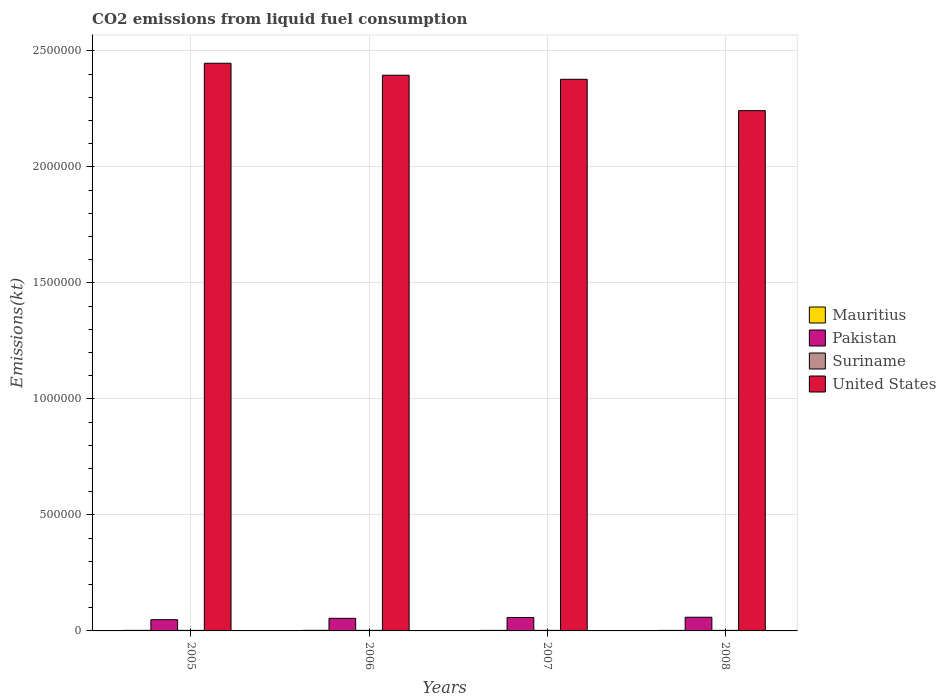How many groups of bars are there?
Provide a short and direct response. 4. Are the number of bars per tick equal to the number of legend labels?
Give a very brief answer. Yes. Are the number of bars on each tick of the X-axis equal?
Ensure brevity in your answer.  Yes. What is the label of the 3rd group of bars from the left?
Give a very brief answer. 2007. What is the amount of CO2 emitted in United States in 2008?
Provide a short and direct response. 2.24e+06. Across all years, what is the maximum amount of CO2 emitted in Pakistan?
Provide a short and direct response. 5.90e+04. Across all years, what is the minimum amount of CO2 emitted in Suriname?
Provide a short and direct response. 2346.88. What is the total amount of CO2 emitted in Mauritius in the graph?
Give a very brief answer. 9526.87. What is the difference between the amount of CO2 emitted in United States in 2005 and that in 2008?
Your response must be concise. 2.04e+05. What is the difference between the amount of CO2 emitted in United States in 2007 and the amount of CO2 emitted in Suriname in 2005?
Make the answer very short. 2.37e+06. What is the average amount of CO2 emitted in United States per year?
Provide a short and direct response. 2.37e+06. In the year 2006, what is the difference between the amount of CO2 emitted in Pakistan and amount of CO2 emitted in Mauritius?
Provide a short and direct response. 5.18e+04. In how many years, is the amount of CO2 emitted in Mauritius greater than 2200000 kt?
Make the answer very short. 0. Is the difference between the amount of CO2 emitted in Pakistan in 2006 and 2008 greater than the difference between the amount of CO2 emitted in Mauritius in 2006 and 2008?
Offer a terse response. No. What is the difference between the highest and the second highest amount of CO2 emitted in Pakistan?
Ensure brevity in your answer.  1052.43. What is the difference between the highest and the lowest amount of CO2 emitted in Mauritius?
Your response must be concise. 267.69. Is the sum of the amount of CO2 emitted in Suriname in 2005 and 2008 greater than the maximum amount of CO2 emitted in Mauritius across all years?
Offer a very short reply. Yes. Is it the case that in every year, the sum of the amount of CO2 emitted in Mauritius and amount of CO2 emitted in United States is greater than the sum of amount of CO2 emitted in Pakistan and amount of CO2 emitted in Suriname?
Give a very brief answer. Yes. What does the 2nd bar from the left in 2006 represents?
Offer a terse response. Pakistan. What does the 1st bar from the right in 2008 represents?
Your response must be concise. United States. Are all the bars in the graph horizontal?
Give a very brief answer. No. What is the difference between two consecutive major ticks on the Y-axis?
Provide a succinct answer. 5.00e+05. Does the graph contain any zero values?
Offer a very short reply. No. Where does the legend appear in the graph?
Your answer should be compact. Center right. What is the title of the graph?
Make the answer very short. CO2 emissions from liquid fuel consumption. What is the label or title of the Y-axis?
Provide a succinct answer. Emissions(kt). What is the Emissions(kt) in Mauritius in 2005?
Your response must be concise. 2442.22. What is the Emissions(kt) of Pakistan in 2005?
Provide a short and direct response. 4.84e+04. What is the Emissions(kt) of Suriname in 2005?
Provide a short and direct response. 2346.88. What is the Emissions(kt) of United States in 2005?
Offer a terse response. 2.45e+06. What is the Emissions(kt) in Mauritius in 2006?
Offer a very short reply. 2493.56. What is the Emissions(kt) of Pakistan in 2006?
Your response must be concise. 5.43e+04. What is the Emissions(kt) in Suriname in 2006?
Your response must be concise. 2409.22. What is the Emissions(kt) in United States in 2006?
Provide a succinct answer. 2.39e+06. What is the Emissions(kt) of Mauritius in 2007?
Your response must be concise. 2365.22. What is the Emissions(kt) of Pakistan in 2007?
Provide a succinct answer. 5.79e+04. What is the Emissions(kt) of Suriname in 2007?
Your answer should be compact. 2409.22. What is the Emissions(kt) of United States in 2007?
Provide a succinct answer. 2.38e+06. What is the Emissions(kt) of Mauritius in 2008?
Your response must be concise. 2225.87. What is the Emissions(kt) in Pakistan in 2008?
Make the answer very short. 5.90e+04. What is the Emissions(kt) in Suriname in 2008?
Keep it short and to the point. 2409.22. What is the Emissions(kt) in United States in 2008?
Offer a very short reply. 2.24e+06. Across all years, what is the maximum Emissions(kt) of Mauritius?
Keep it short and to the point. 2493.56. Across all years, what is the maximum Emissions(kt) in Pakistan?
Your response must be concise. 5.90e+04. Across all years, what is the maximum Emissions(kt) in Suriname?
Your response must be concise. 2409.22. Across all years, what is the maximum Emissions(kt) of United States?
Provide a succinct answer. 2.45e+06. Across all years, what is the minimum Emissions(kt) of Mauritius?
Your answer should be very brief. 2225.87. Across all years, what is the minimum Emissions(kt) of Pakistan?
Make the answer very short. 4.84e+04. Across all years, what is the minimum Emissions(kt) of Suriname?
Make the answer very short. 2346.88. Across all years, what is the minimum Emissions(kt) of United States?
Keep it short and to the point. 2.24e+06. What is the total Emissions(kt) of Mauritius in the graph?
Keep it short and to the point. 9526.87. What is the total Emissions(kt) in Pakistan in the graph?
Provide a succinct answer. 2.20e+05. What is the total Emissions(kt) of Suriname in the graph?
Make the answer very short. 9574.54. What is the total Emissions(kt) of United States in the graph?
Offer a very short reply. 9.46e+06. What is the difference between the Emissions(kt) in Mauritius in 2005 and that in 2006?
Keep it short and to the point. -51.34. What is the difference between the Emissions(kt) of Pakistan in 2005 and that in 2006?
Your response must be concise. -5859.87. What is the difference between the Emissions(kt) in Suriname in 2005 and that in 2006?
Provide a succinct answer. -62.34. What is the difference between the Emissions(kt) of United States in 2005 and that in 2006?
Ensure brevity in your answer.  5.15e+04. What is the difference between the Emissions(kt) in Mauritius in 2005 and that in 2007?
Give a very brief answer. 77.01. What is the difference between the Emissions(kt) in Pakistan in 2005 and that in 2007?
Keep it short and to the point. -9519.53. What is the difference between the Emissions(kt) in Suriname in 2005 and that in 2007?
Offer a very short reply. -62.34. What is the difference between the Emissions(kt) of United States in 2005 and that in 2007?
Offer a terse response. 6.92e+04. What is the difference between the Emissions(kt) in Mauritius in 2005 and that in 2008?
Keep it short and to the point. 216.35. What is the difference between the Emissions(kt) of Pakistan in 2005 and that in 2008?
Offer a terse response. -1.06e+04. What is the difference between the Emissions(kt) of Suriname in 2005 and that in 2008?
Keep it short and to the point. -62.34. What is the difference between the Emissions(kt) in United States in 2005 and that in 2008?
Your answer should be compact. 2.04e+05. What is the difference between the Emissions(kt) of Mauritius in 2006 and that in 2007?
Provide a short and direct response. 128.34. What is the difference between the Emissions(kt) in Pakistan in 2006 and that in 2007?
Keep it short and to the point. -3659.67. What is the difference between the Emissions(kt) in Suriname in 2006 and that in 2007?
Give a very brief answer. 0. What is the difference between the Emissions(kt) of United States in 2006 and that in 2007?
Provide a succinct answer. 1.77e+04. What is the difference between the Emissions(kt) of Mauritius in 2006 and that in 2008?
Your answer should be compact. 267.69. What is the difference between the Emissions(kt) of Pakistan in 2006 and that in 2008?
Keep it short and to the point. -4712.1. What is the difference between the Emissions(kt) of Suriname in 2006 and that in 2008?
Your answer should be compact. 0. What is the difference between the Emissions(kt) of United States in 2006 and that in 2008?
Offer a very short reply. 1.53e+05. What is the difference between the Emissions(kt) in Mauritius in 2007 and that in 2008?
Give a very brief answer. 139.35. What is the difference between the Emissions(kt) of Pakistan in 2007 and that in 2008?
Your answer should be very brief. -1052.43. What is the difference between the Emissions(kt) in Suriname in 2007 and that in 2008?
Offer a very short reply. 0. What is the difference between the Emissions(kt) of United States in 2007 and that in 2008?
Make the answer very short. 1.35e+05. What is the difference between the Emissions(kt) in Mauritius in 2005 and the Emissions(kt) in Pakistan in 2006?
Keep it short and to the point. -5.18e+04. What is the difference between the Emissions(kt) of Mauritius in 2005 and the Emissions(kt) of Suriname in 2006?
Your answer should be compact. 33. What is the difference between the Emissions(kt) in Mauritius in 2005 and the Emissions(kt) in United States in 2006?
Make the answer very short. -2.39e+06. What is the difference between the Emissions(kt) of Pakistan in 2005 and the Emissions(kt) of Suriname in 2006?
Offer a very short reply. 4.60e+04. What is the difference between the Emissions(kt) in Pakistan in 2005 and the Emissions(kt) in United States in 2006?
Your answer should be very brief. -2.35e+06. What is the difference between the Emissions(kt) of Suriname in 2005 and the Emissions(kt) of United States in 2006?
Keep it short and to the point. -2.39e+06. What is the difference between the Emissions(kt) in Mauritius in 2005 and the Emissions(kt) in Pakistan in 2007?
Give a very brief answer. -5.55e+04. What is the difference between the Emissions(kt) of Mauritius in 2005 and the Emissions(kt) of Suriname in 2007?
Your answer should be compact. 33. What is the difference between the Emissions(kt) of Mauritius in 2005 and the Emissions(kt) of United States in 2007?
Your answer should be very brief. -2.37e+06. What is the difference between the Emissions(kt) in Pakistan in 2005 and the Emissions(kt) in Suriname in 2007?
Your response must be concise. 4.60e+04. What is the difference between the Emissions(kt) of Pakistan in 2005 and the Emissions(kt) of United States in 2007?
Your answer should be compact. -2.33e+06. What is the difference between the Emissions(kt) of Suriname in 2005 and the Emissions(kt) of United States in 2007?
Your answer should be compact. -2.37e+06. What is the difference between the Emissions(kt) of Mauritius in 2005 and the Emissions(kt) of Pakistan in 2008?
Provide a short and direct response. -5.65e+04. What is the difference between the Emissions(kt) in Mauritius in 2005 and the Emissions(kt) in Suriname in 2008?
Provide a short and direct response. 33. What is the difference between the Emissions(kt) in Mauritius in 2005 and the Emissions(kt) in United States in 2008?
Your answer should be compact. -2.24e+06. What is the difference between the Emissions(kt) in Pakistan in 2005 and the Emissions(kt) in Suriname in 2008?
Make the answer very short. 4.60e+04. What is the difference between the Emissions(kt) of Pakistan in 2005 and the Emissions(kt) of United States in 2008?
Provide a short and direct response. -2.19e+06. What is the difference between the Emissions(kt) in Suriname in 2005 and the Emissions(kt) in United States in 2008?
Your answer should be compact. -2.24e+06. What is the difference between the Emissions(kt) in Mauritius in 2006 and the Emissions(kt) in Pakistan in 2007?
Ensure brevity in your answer.  -5.54e+04. What is the difference between the Emissions(kt) in Mauritius in 2006 and the Emissions(kt) in Suriname in 2007?
Provide a short and direct response. 84.34. What is the difference between the Emissions(kt) in Mauritius in 2006 and the Emissions(kt) in United States in 2007?
Provide a short and direct response. -2.37e+06. What is the difference between the Emissions(kt) in Pakistan in 2006 and the Emissions(kt) in Suriname in 2007?
Ensure brevity in your answer.  5.19e+04. What is the difference between the Emissions(kt) in Pakistan in 2006 and the Emissions(kt) in United States in 2007?
Offer a very short reply. -2.32e+06. What is the difference between the Emissions(kt) in Suriname in 2006 and the Emissions(kt) in United States in 2007?
Ensure brevity in your answer.  -2.37e+06. What is the difference between the Emissions(kt) of Mauritius in 2006 and the Emissions(kt) of Pakistan in 2008?
Provide a short and direct response. -5.65e+04. What is the difference between the Emissions(kt) of Mauritius in 2006 and the Emissions(kt) of Suriname in 2008?
Provide a succinct answer. 84.34. What is the difference between the Emissions(kt) in Mauritius in 2006 and the Emissions(kt) in United States in 2008?
Your answer should be compact. -2.24e+06. What is the difference between the Emissions(kt) of Pakistan in 2006 and the Emissions(kt) of Suriname in 2008?
Your answer should be very brief. 5.19e+04. What is the difference between the Emissions(kt) of Pakistan in 2006 and the Emissions(kt) of United States in 2008?
Give a very brief answer. -2.19e+06. What is the difference between the Emissions(kt) of Suriname in 2006 and the Emissions(kt) of United States in 2008?
Your response must be concise. -2.24e+06. What is the difference between the Emissions(kt) of Mauritius in 2007 and the Emissions(kt) of Pakistan in 2008?
Offer a terse response. -5.66e+04. What is the difference between the Emissions(kt) in Mauritius in 2007 and the Emissions(kt) in Suriname in 2008?
Ensure brevity in your answer.  -44. What is the difference between the Emissions(kt) in Mauritius in 2007 and the Emissions(kt) in United States in 2008?
Offer a terse response. -2.24e+06. What is the difference between the Emissions(kt) of Pakistan in 2007 and the Emissions(kt) of Suriname in 2008?
Give a very brief answer. 5.55e+04. What is the difference between the Emissions(kt) of Pakistan in 2007 and the Emissions(kt) of United States in 2008?
Make the answer very short. -2.18e+06. What is the difference between the Emissions(kt) of Suriname in 2007 and the Emissions(kt) of United States in 2008?
Your answer should be compact. -2.24e+06. What is the average Emissions(kt) of Mauritius per year?
Offer a terse response. 2381.72. What is the average Emissions(kt) in Pakistan per year?
Keep it short and to the point. 5.49e+04. What is the average Emissions(kt) in Suriname per year?
Keep it short and to the point. 2393.63. What is the average Emissions(kt) of United States per year?
Offer a terse response. 2.37e+06. In the year 2005, what is the difference between the Emissions(kt) of Mauritius and Emissions(kt) of Pakistan?
Provide a succinct answer. -4.60e+04. In the year 2005, what is the difference between the Emissions(kt) in Mauritius and Emissions(kt) in Suriname?
Offer a terse response. 95.34. In the year 2005, what is the difference between the Emissions(kt) of Mauritius and Emissions(kt) of United States?
Offer a very short reply. -2.44e+06. In the year 2005, what is the difference between the Emissions(kt) of Pakistan and Emissions(kt) of Suriname?
Ensure brevity in your answer.  4.61e+04. In the year 2005, what is the difference between the Emissions(kt) in Pakistan and Emissions(kt) in United States?
Make the answer very short. -2.40e+06. In the year 2005, what is the difference between the Emissions(kt) in Suriname and Emissions(kt) in United States?
Your answer should be compact. -2.44e+06. In the year 2006, what is the difference between the Emissions(kt) in Mauritius and Emissions(kt) in Pakistan?
Offer a terse response. -5.18e+04. In the year 2006, what is the difference between the Emissions(kt) in Mauritius and Emissions(kt) in Suriname?
Your response must be concise. 84.34. In the year 2006, what is the difference between the Emissions(kt) of Mauritius and Emissions(kt) of United States?
Your response must be concise. -2.39e+06. In the year 2006, what is the difference between the Emissions(kt) of Pakistan and Emissions(kt) of Suriname?
Offer a very short reply. 5.19e+04. In the year 2006, what is the difference between the Emissions(kt) in Pakistan and Emissions(kt) in United States?
Provide a succinct answer. -2.34e+06. In the year 2006, what is the difference between the Emissions(kt) of Suriname and Emissions(kt) of United States?
Ensure brevity in your answer.  -2.39e+06. In the year 2007, what is the difference between the Emissions(kt) in Mauritius and Emissions(kt) in Pakistan?
Your answer should be compact. -5.56e+04. In the year 2007, what is the difference between the Emissions(kt) in Mauritius and Emissions(kt) in Suriname?
Give a very brief answer. -44. In the year 2007, what is the difference between the Emissions(kt) of Mauritius and Emissions(kt) of United States?
Provide a short and direct response. -2.37e+06. In the year 2007, what is the difference between the Emissions(kt) of Pakistan and Emissions(kt) of Suriname?
Ensure brevity in your answer.  5.55e+04. In the year 2007, what is the difference between the Emissions(kt) in Pakistan and Emissions(kt) in United States?
Your response must be concise. -2.32e+06. In the year 2007, what is the difference between the Emissions(kt) of Suriname and Emissions(kt) of United States?
Provide a short and direct response. -2.37e+06. In the year 2008, what is the difference between the Emissions(kt) of Mauritius and Emissions(kt) of Pakistan?
Provide a succinct answer. -5.68e+04. In the year 2008, what is the difference between the Emissions(kt) in Mauritius and Emissions(kt) in Suriname?
Keep it short and to the point. -183.35. In the year 2008, what is the difference between the Emissions(kt) in Mauritius and Emissions(kt) in United States?
Keep it short and to the point. -2.24e+06. In the year 2008, what is the difference between the Emissions(kt) in Pakistan and Emissions(kt) in Suriname?
Your answer should be very brief. 5.66e+04. In the year 2008, what is the difference between the Emissions(kt) in Pakistan and Emissions(kt) in United States?
Provide a succinct answer. -2.18e+06. In the year 2008, what is the difference between the Emissions(kt) of Suriname and Emissions(kt) of United States?
Your response must be concise. -2.24e+06. What is the ratio of the Emissions(kt) of Mauritius in 2005 to that in 2006?
Offer a terse response. 0.98. What is the ratio of the Emissions(kt) of Pakistan in 2005 to that in 2006?
Ensure brevity in your answer.  0.89. What is the ratio of the Emissions(kt) of Suriname in 2005 to that in 2006?
Your answer should be compact. 0.97. What is the ratio of the Emissions(kt) in United States in 2005 to that in 2006?
Offer a very short reply. 1.02. What is the ratio of the Emissions(kt) of Mauritius in 2005 to that in 2007?
Provide a succinct answer. 1.03. What is the ratio of the Emissions(kt) in Pakistan in 2005 to that in 2007?
Your answer should be compact. 0.84. What is the ratio of the Emissions(kt) of Suriname in 2005 to that in 2007?
Provide a short and direct response. 0.97. What is the ratio of the Emissions(kt) in United States in 2005 to that in 2007?
Make the answer very short. 1.03. What is the ratio of the Emissions(kt) of Mauritius in 2005 to that in 2008?
Offer a terse response. 1.1. What is the ratio of the Emissions(kt) of Pakistan in 2005 to that in 2008?
Offer a very short reply. 0.82. What is the ratio of the Emissions(kt) in Suriname in 2005 to that in 2008?
Keep it short and to the point. 0.97. What is the ratio of the Emissions(kt) of United States in 2005 to that in 2008?
Your answer should be very brief. 1.09. What is the ratio of the Emissions(kt) in Mauritius in 2006 to that in 2007?
Provide a short and direct response. 1.05. What is the ratio of the Emissions(kt) in Pakistan in 2006 to that in 2007?
Your answer should be compact. 0.94. What is the ratio of the Emissions(kt) in Suriname in 2006 to that in 2007?
Keep it short and to the point. 1. What is the ratio of the Emissions(kt) of United States in 2006 to that in 2007?
Your response must be concise. 1.01. What is the ratio of the Emissions(kt) of Mauritius in 2006 to that in 2008?
Ensure brevity in your answer.  1.12. What is the ratio of the Emissions(kt) in Pakistan in 2006 to that in 2008?
Your response must be concise. 0.92. What is the ratio of the Emissions(kt) of United States in 2006 to that in 2008?
Provide a short and direct response. 1.07. What is the ratio of the Emissions(kt) of Mauritius in 2007 to that in 2008?
Offer a terse response. 1.06. What is the ratio of the Emissions(kt) in Pakistan in 2007 to that in 2008?
Provide a short and direct response. 0.98. What is the ratio of the Emissions(kt) of United States in 2007 to that in 2008?
Your answer should be very brief. 1.06. What is the difference between the highest and the second highest Emissions(kt) in Mauritius?
Ensure brevity in your answer.  51.34. What is the difference between the highest and the second highest Emissions(kt) in Pakistan?
Offer a terse response. 1052.43. What is the difference between the highest and the second highest Emissions(kt) in United States?
Provide a short and direct response. 5.15e+04. What is the difference between the highest and the lowest Emissions(kt) of Mauritius?
Ensure brevity in your answer.  267.69. What is the difference between the highest and the lowest Emissions(kt) in Pakistan?
Your response must be concise. 1.06e+04. What is the difference between the highest and the lowest Emissions(kt) in Suriname?
Your answer should be very brief. 62.34. What is the difference between the highest and the lowest Emissions(kt) of United States?
Keep it short and to the point. 2.04e+05. 